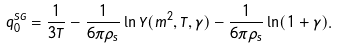Convert formula to latex. <formula><loc_0><loc_0><loc_500><loc_500>\bar { q } _ { 0 } ^ { S G } = \frac { 1 } { 3 T } - \frac { 1 } { 6 \pi \rho _ { s } } \ln \Upsilon ( m ^ { 2 } , T , \gamma ) - \frac { 1 } { 6 \pi \rho _ { s } } \ln ( 1 + \gamma ) .</formula> 